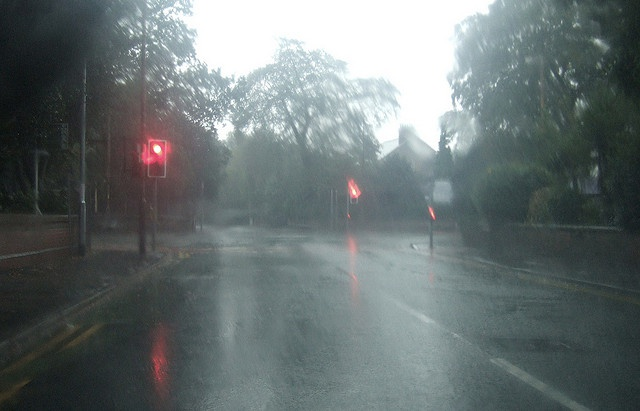Describe the objects in this image and their specific colors. I can see traffic light in black, salmon, and brown tones and traffic light in black, lightpink, and gray tones in this image. 